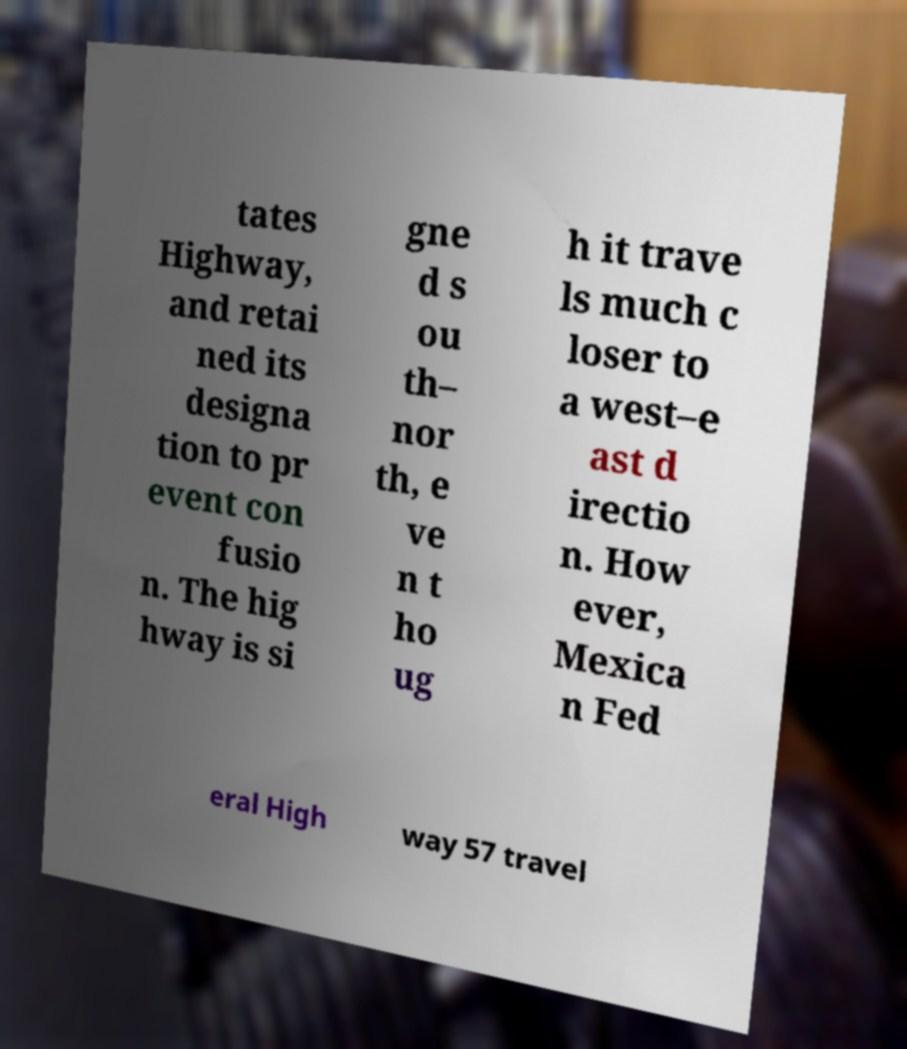Can you accurately transcribe the text from the provided image for me? tates Highway, and retai ned its designa tion to pr event con fusio n. The hig hway is si gne d s ou th– nor th, e ve n t ho ug h it trave ls much c loser to a west–e ast d irectio n. How ever, Mexica n Fed eral High way 57 travel 